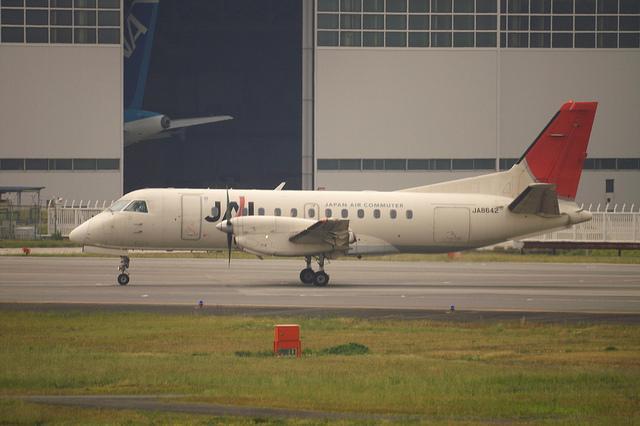What color is the tip of the tailfin on the Japanese propeller plane?
Select the accurate answer and provide explanation: 'Answer: answer
Rationale: rationale.'
Options: Green, orange, red, brown. Answer: red.
Rationale: It shows a color that's similar to those cups used in beer pong. 